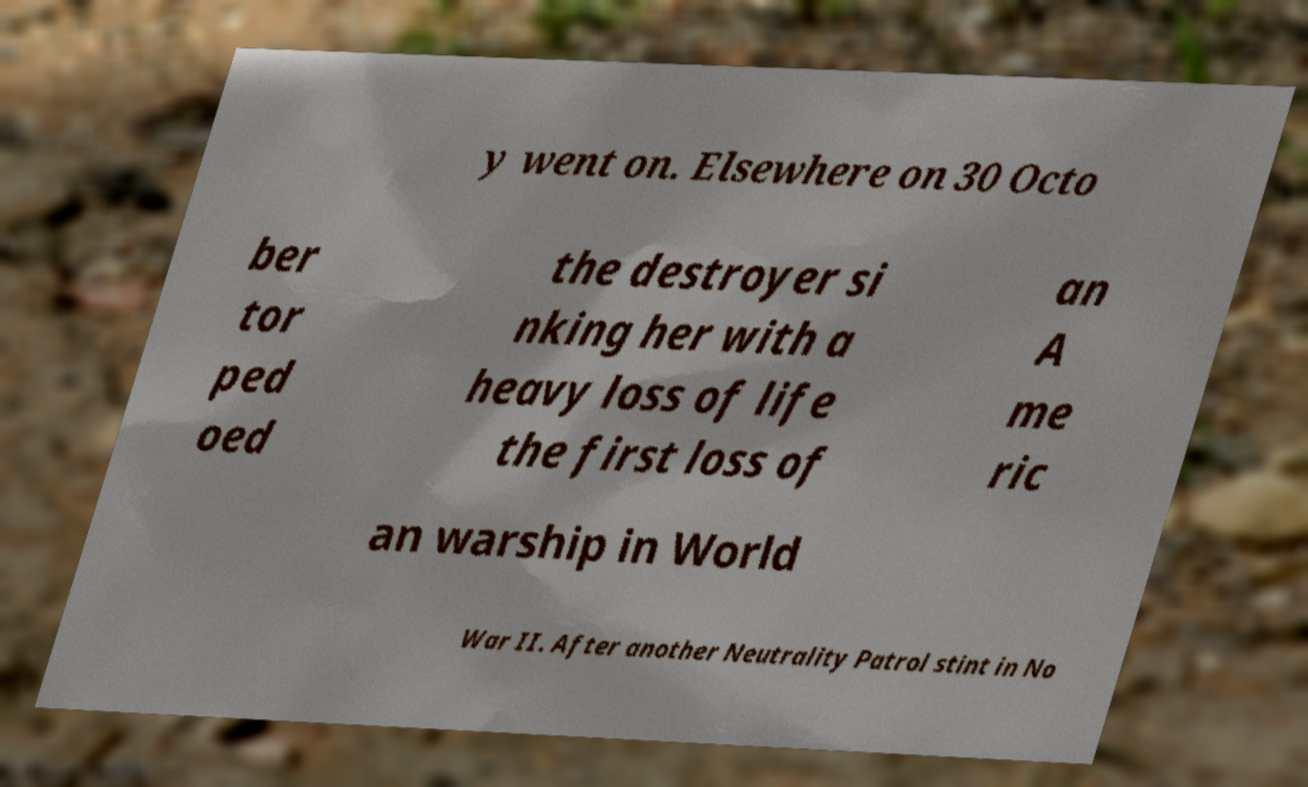Could you extract and type out the text from this image? y went on. Elsewhere on 30 Octo ber tor ped oed the destroyer si nking her with a heavy loss of life the first loss of an A me ric an warship in World War II. After another Neutrality Patrol stint in No 